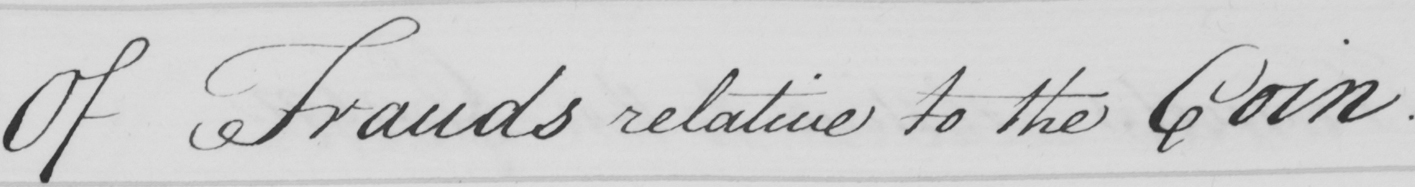Transcribe the text shown in this historical manuscript line. Of Frauds relative to the Coin . 